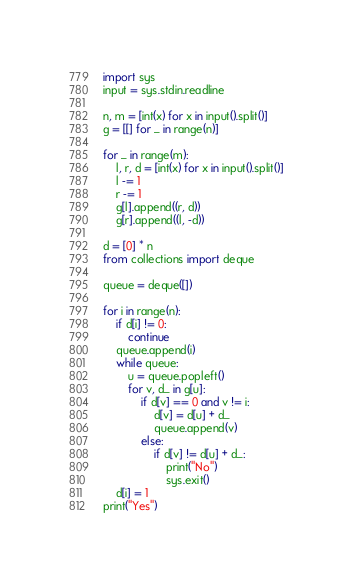Convert code to text. <code><loc_0><loc_0><loc_500><loc_500><_Python_>import sys
input = sys.stdin.readline

n, m = [int(x) for x in input().split()]
g = [[] for _ in range(n)]

for _ in range(m):
    l, r, d = [int(x) for x in input().split()]
    l -= 1
    r -= 1
    g[l].append((r, d))
    g[r].append((l, -d))

d = [0] * n
from collections import deque

queue = deque([])

for i in range(n):
    if d[i] != 0:
        continue
    queue.append(i)
    while queue:
        u = queue.popleft()
        for v, d_ in g[u]:
            if d[v] == 0 and v != i:
                d[v] = d[u] + d_
                queue.append(v)
            else:
                if d[v] != d[u] + d_:
                    print("No")
                    sys.exit()
    d[i] = 1
print("Yes")
</code> 